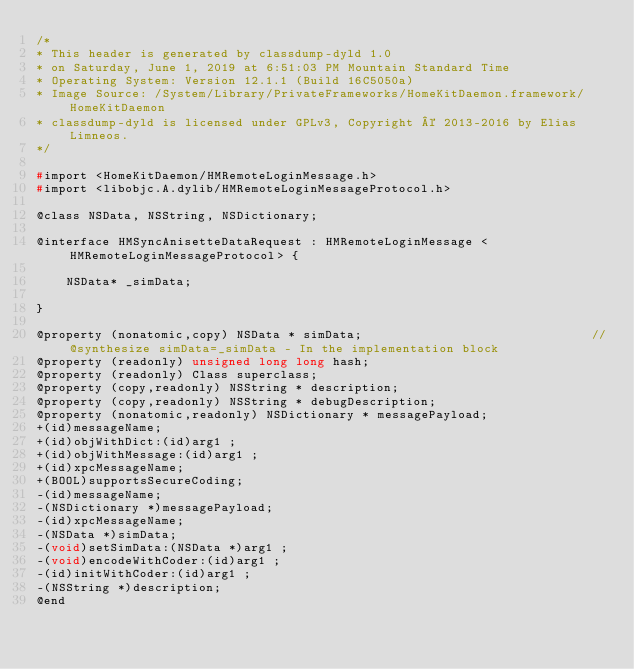<code> <loc_0><loc_0><loc_500><loc_500><_C_>/*
* This header is generated by classdump-dyld 1.0
* on Saturday, June 1, 2019 at 6:51:03 PM Mountain Standard Time
* Operating System: Version 12.1.1 (Build 16C5050a)
* Image Source: /System/Library/PrivateFrameworks/HomeKitDaemon.framework/HomeKitDaemon
* classdump-dyld is licensed under GPLv3, Copyright © 2013-2016 by Elias Limneos.
*/

#import <HomeKitDaemon/HMRemoteLoginMessage.h>
#import <libobjc.A.dylib/HMRemoteLoginMessageProtocol.h>

@class NSData, NSString, NSDictionary;

@interface HMSyncAnisetteDataRequest : HMRemoteLoginMessage <HMRemoteLoginMessageProtocol> {

	NSData* _simData;

}

@property (nonatomic,copy) NSData * simData;                               //@synthesize simData=_simData - In the implementation block
@property (readonly) unsigned long long hash; 
@property (readonly) Class superclass; 
@property (copy,readonly) NSString * description; 
@property (copy,readonly) NSString * debugDescription; 
@property (nonatomic,readonly) NSDictionary * messagePayload; 
+(id)messageName;
+(id)objWithDict:(id)arg1 ;
+(id)objWithMessage:(id)arg1 ;
+(id)xpcMessageName;
+(BOOL)supportsSecureCoding;
-(id)messageName;
-(NSDictionary *)messagePayload;
-(id)xpcMessageName;
-(NSData *)simData;
-(void)setSimData:(NSData *)arg1 ;
-(void)encodeWithCoder:(id)arg1 ;
-(id)initWithCoder:(id)arg1 ;
-(NSString *)description;
@end

</code> 